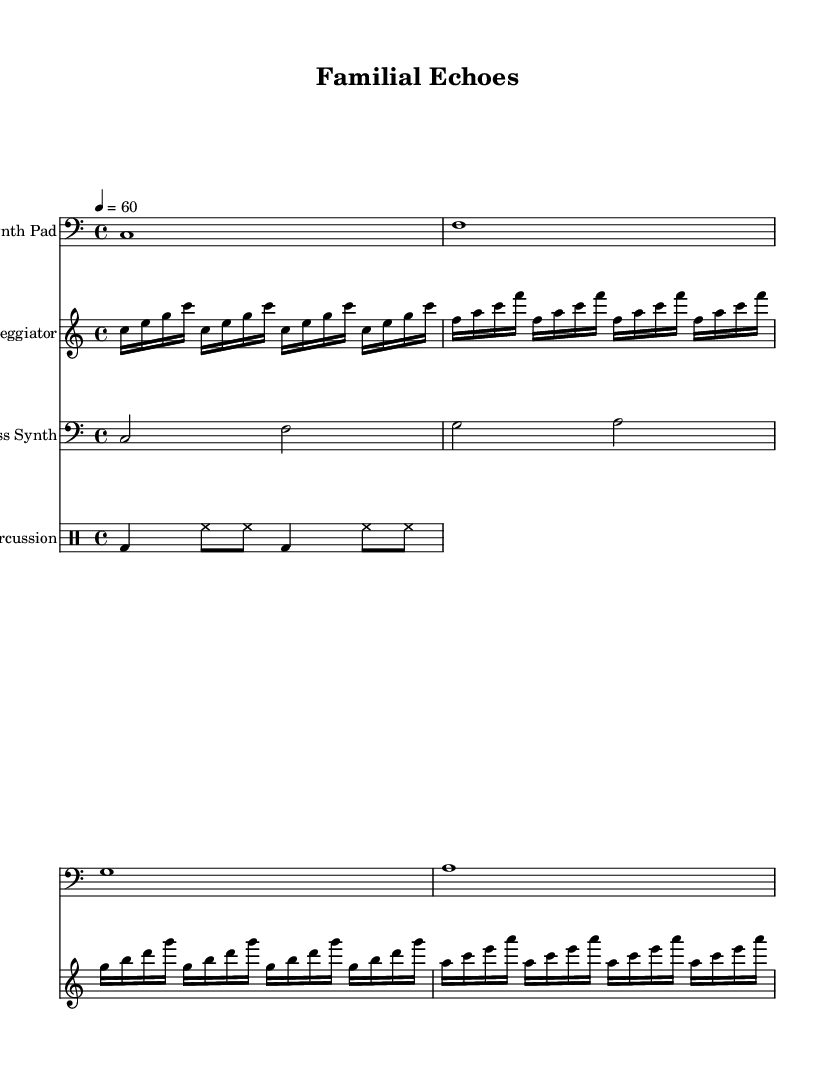what is the key signature of this music? The key signature is C major, which has no sharps or flats.
Answer: C major what is the time signature of this music? The time signature is indicated by the fraction at the beginning, which shows that each measure contains four beats, with a quarter note getting one beat.
Answer: 4/4 what is the tempo marking of this piece? The tempo marking indicates the speed of the piece is set to 60 beats per minute, shown by the '4 = 60' notation.
Answer: 60 how many measures are in the synth pad part? By counting the distinct musical sections in the synth pad staff, we find that there are four measures total.
Answer: 4 what rhythmic pattern does the percussion play? The percussion plays a combination of bass drum and hi-hat on a consistent pattern, which can be analyzed to see it's structured in alternating beats per measure.
Answer: bass drum and hi-hat which instruments are included in this composition? By looking at the staff headers, we can identify that the composition includes synth pad, arpeggiator, bass synth, and percussion as distinct instrument parts.
Answer: synth pad, arpeggiator, bass synth, percussion how is the arpeggiator structured over the measures? Examining the arpeggiator staff, we see it includes repeating arpeggiated notes across four measures in a structured pattern, with each set of four counts corresponding to specific notes.
Answer: four measures of arpeggiated notes 